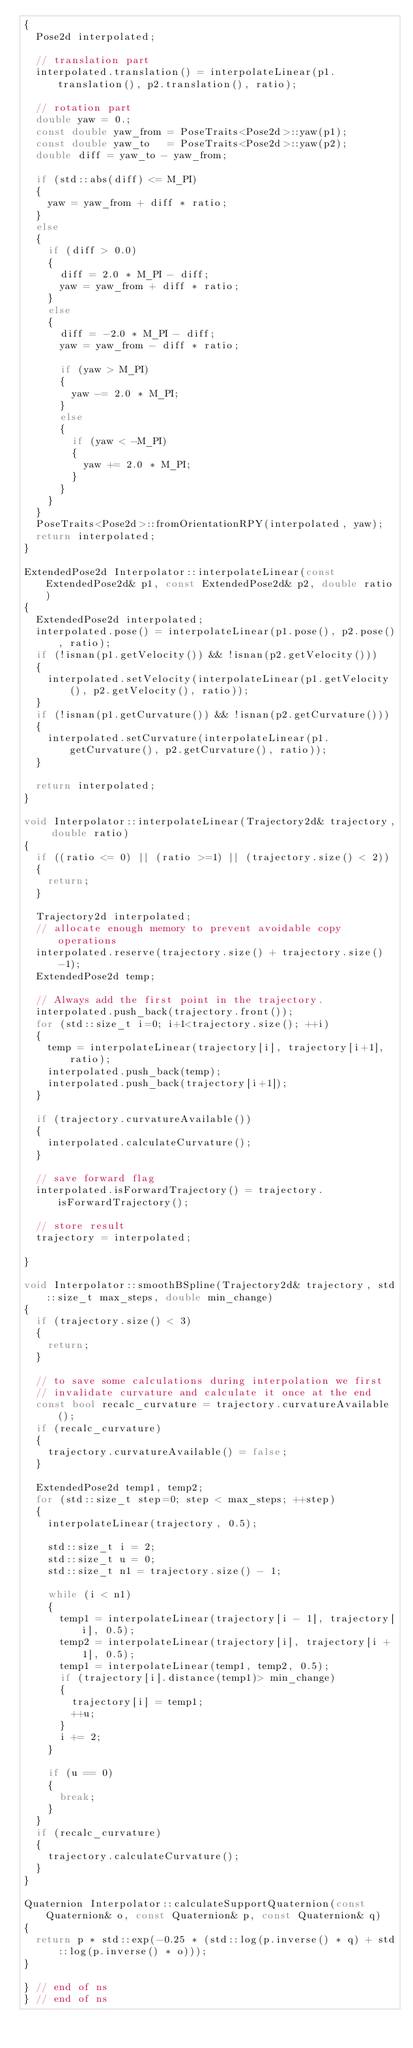<code> <loc_0><loc_0><loc_500><loc_500><_C++_>{
  Pose2d interpolated;

  // translation part
  interpolated.translation() = interpolateLinear(p1.translation(), p2.translation(), ratio);

  // rotation part
  double yaw = 0.;
  const double yaw_from = PoseTraits<Pose2d>::yaw(p1);
  const double yaw_to   = PoseTraits<Pose2d>::yaw(p2);
  double diff = yaw_to - yaw_from;

  if (std::abs(diff) <= M_PI)
  {
    yaw = yaw_from + diff * ratio;
  }
  else
  {
    if (diff > 0.0)
    {
      diff = 2.0 * M_PI - diff;
	  yaw = yaw_from + diff * ratio;
    }
    else
    {
      diff = -2.0 * M_PI - diff;
      yaw = yaw_from - diff * ratio;

      if (yaw > M_PI)
      {
        yaw -= 2.0 * M_PI;
      }
      else
      {
        if (yaw < -M_PI)
        {
          yaw += 2.0 * M_PI;
        }
      }
    }
  }
  PoseTraits<Pose2d>::fromOrientationRPY(interpolated, yaw);
  return interpolated;
}

ExtendedPose2d Interpolator::interpolateLinear(const ExtendedPose2d& p1, const ExtendedPose2d& p2, double ratio)
{
  ExtendedPose2d interpolated;
  interpolated.pose() = interpolateLinear(p1.pose(), p2.pose(), ratio);
  if (!isnan(p1.getVelocity()) && !isnan(p2.getVelocity()))
  {
    interpolated.setVelocity(interpolateLinear(p1.getVelocity(), p2.getVelocity(), ratio));
  }
  if (!isnan(p1.getCurvature()) && !isnan(p2.getCurvature()))
  {
    interpolated.setCurvature(interpolateLinear(p1.getCurvature(), p2.getCurvature(), ratio));
  }

  return interpolated;
}

void Interpolator::interpolateLinear(Trajectory2d& trajectory, double ratio)
{
  if ((ratio <= 0) || (ratio >=1) || (trajectory.size() < 2))
  {
    return;
  }

  Trajectory2d interpolated;
  // allocate enough memory to prevent avoidable copy operations
  interpolated.reserve(trajectory.size() + trajectory.size()-1);
  ExtendedPose2d temp;

  // Always add the first point in the trajectory.
  interpolated.push_back(trajectory.front());
  for (std::size_t i=0; i+1<trajectory.size(); ++i)
  {
    temp = interpolateLinear(trajectory[i], trajectory[i+1], ratio);
    interpolated.push_back(temp);
    interpolated.push_back(trajectory[i+1]);
  }

  if (trajectory.curvatureAvailable())
  {
    interpolated.calculateCurvature();
  }

  // save forward flag
  interpolated.isForwardTrajectory() = trajectory.isForwardTrajectory();

  // store result
  trajectory = interpolated;

}

void Interpolator::smoothBSpline(Trajectory2d& trajectory, std::size_t max_steps, double min_change)
{
  if (trajectory.size() < 3)
  {
    return;
  }

  // to save some calculations during interpolation we first
  // invalidate curvature and calculate it once at the end
  const bool recalc_curvature = trajectory.curvatureAvailable();
  if (recalc_curvature)
  {
    trajectory.curvatureAvailable() = false;
  }

  ExtendedPose2d temp1, temp2;
  for (std::size_t step=0; step < max_steps; ++step)
  {
    interpolateLinear(trajectory, 0.5);

    std::size_t i = 2;
    std::size_t u = 0;
    std::size_t n1 = trajectory.size() - 1;

    while (i < n1)
    {
      temp1 = interpolateLinear(trajectory[i - 1], trajectory[i], 0.5);
      temp2 = interpolateLinear(trajectory[i], trajectory[i + 1], 0.5);
      temp1 = interpolateLinear(temp1, temp2, 0.5);
      if (trajectory[i].distance(temp1)> min_change)
      {
        trajectory[i] = temp1;
        ++u;
      }
      i += 2;
    }

    if (u == 0)
    {
      break;
    }
  }
  if (recalc_curvature)
  {
    trajectory.calculateCurvature();
  }
}

Quaternion Interpolator::calculateSupportQuaternion(const Quaternion& o, const Quaternion& p, const Quaternion& q)
{
  return p * std::exp(-0.25 * (std::log(p.inverse() * q) + std::log(p.inverse() * o)));
}

} // end of ns
} // end of ns
</code> 